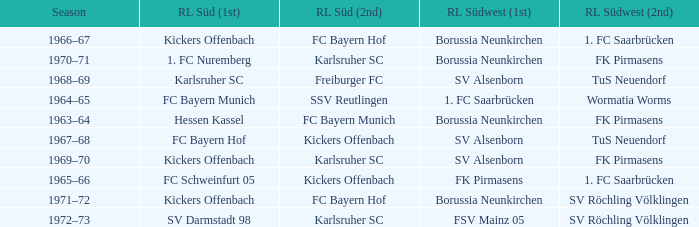What season was Freiburger FC the RL Süd (2nd) team? 1968–69. 